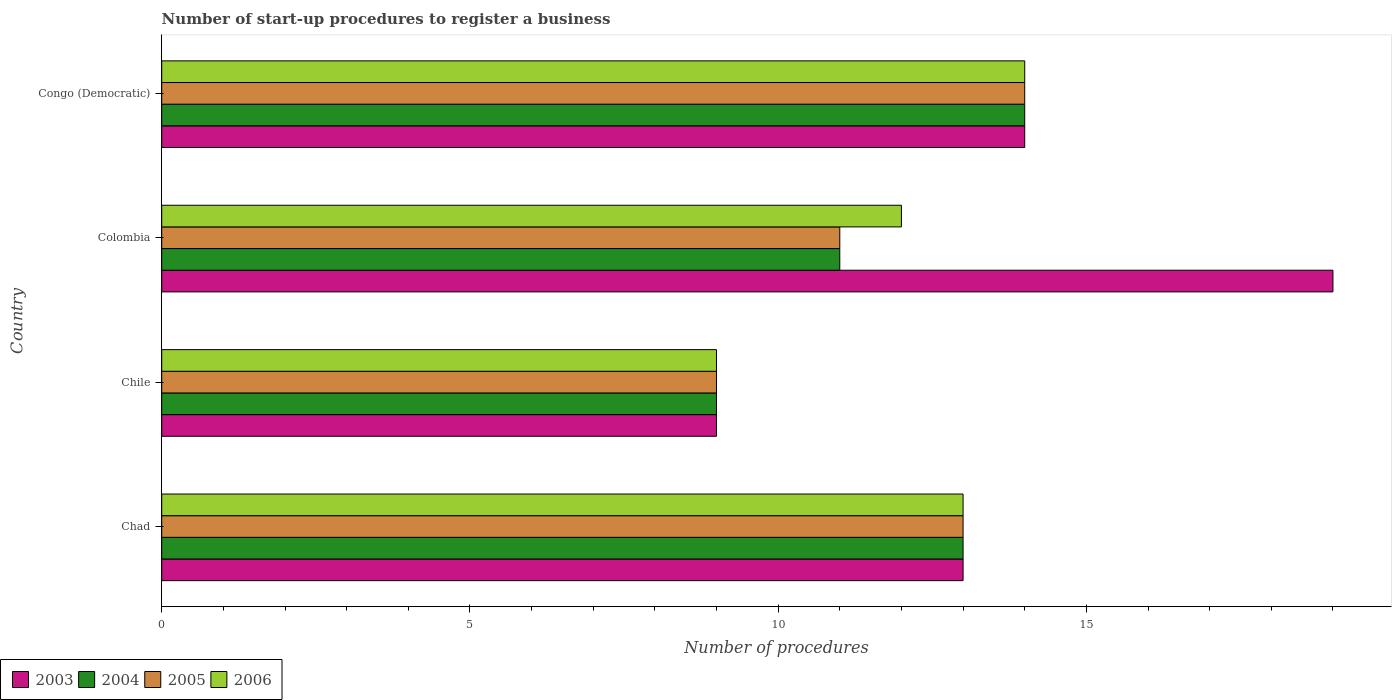How many different coloured bars are there?
Your answer should be very brief. 4. How many groups of bars are there?
Offer a very short reply. 4. Are the number of bars per tick equal to the number of legend labels?
Your response must be concise. Yes. Are the number of bars on each tick of the Y-axis equal?
Your response must be concise. Yes. How many bars are there on the 2nd tick from the top?
Keep it short and to the point. 4. How many bars are there on the 4th tick from the bottom?
Ensure brevity in your answer.  4. What is the label of the 3rd group of bars from the top?
Your answer should be very brief. Chile. What is the number of procedures required to register a business in 2005 in Congo (Democratic)?
Your answer should be very brief. 14. Across all countries, what is the maximum number of procedures required to register a business in 2005?
Ensure brevity in your answer.  14. Across all countries, what is the minimum number of procedures required to register a business in 2004?
Your answer should be very brief. 9. What is the total number of procedures required to register a business in 2005 in the graph?
Give a very brief answer. 47. What is the difference between the number of procedures required to register a business in 2006 in Chile and that in Congo (Democratic)?
Offer a very short reply. -5. What is the difference between the number of procedures required to register a business in 2004 in Congo (Democratic) and the number of procedures required to register a business in 2006 in Colombia?
Your answer should be compact. 2. What is the average number of procedures required to register a business in 2003 per country?
Make the answer very short. 13.75. In how many countries, is the number of procedures required to register a business in 2006 greater than 13 ?
Provide a short and direct response. 1. What is the ratio of the number of procedures required to register a business in 2003 in Colombia to that in Congo (Democratic)?
Provide a short and direct response. 1.36. Is the number of procedures required to register a business in 2005 in Colombia less than that in Congo (Democratic)?
Your answer should be very brief. Yes. In how many countries, is the number of procedures required to register a business in 2004 greater than the average number of procedures required to register a business in 2004 taken over all countries?
Give a very brief answer. 2. Is it the case that in every country, the sum of the number of procedures required to register a business in 2006 and number of procedures required to register a business in 2003 is greater than the sum of number of procedures required to register a business in 2005 and number of procedures required to register a business in 2004?
Provide a succinct answer. No. What does the 1st bar from the top in Congo (Democratic) represents?
Ensure brevity in your answer.  2006. Are all the bars in the graph horizontal?
Offer a very short reply. Yes. How many countries are there in the graph?
Provide a short and direct response. 4. What is the difference between two consecutive major ticks on the X-axis?
Your response must be concise. 5. Are the values on the major ticks of X-axis written in scientific E-notation?
Your answer should be very brief. No. Where does the legend appear in the graph?
Your answer should be compact. Bottom left. What is the title of the graph?
Keep it short and to the point. Number of start-up procedures to register a business. Does "1994" appear as one of the legend labels in the graph?
Your answer should be compact. No. What is the label or title of the X-axis?
Ensure brevity in your answer.  Number of procedures. What is the Number of procedures of 2004 in Chad?
Offer a terse response. 13. What is the Number of procedures in 2006 in Chad?
Offer a terse response. 13. What is the Number of procedures of 2005 in Chile?
Offer a terse response. 9. What is the Number of procedures in 2003 in Colombia?
Keep it short and to the point. 19. What is the Number of procedures in 2004 in Colombia?
Make the answer very short. 11. What is the Number of procedures in 2006 in Colombia?
Provide a succinct answer. 12. What is the Number of procedures of 2005 in Congo (Democratic)?
Keep it short and to the point. 14. What is the Number of procedures of 2006 in Congo (Democratic)?
Provide a short and direct response. 14. Across all countries, what is the maximum Number of procedures in 2003?
Provide a short and direct response. 19. Across all countries, what is the maximum Number of procedures of 2005?
Keep it short and to the point. 14. Across all countries, what is the minimum Number of procedures of 2005?
Your answer should be compact. 9. Across all countries, what is the minimum Number of procedures in 2006?
Keep it short and to the point. 9. What is the total Number of procedures in 2004 in the graph?
Your answer should be very brief. 47. What is the total Number of procedures of 2005 in the graph?
Keep it short and to the point. 47. What is the difference between the Number of procedures of 2005 in Chad and that in Chile?
Ensure brevity in your answer.  4. What is the difference between the Number of procedures in 2003 in Chad and that in Colombia?
Make the answer very short. -6. What is the difference between the Number of procedures of 2005 in Chad and that in Colombia?
Provide a succinct answer. 2. What is the difference between the Number of procedures of 2005 in Chad and that in Congo (Democratic)?
Your response must be concise. -1. What is the difference between the Number of procedures of 2006 in Chad and that in Congo (Democratic)?
Keep it short and to the point. -1. What is the difference between the Number of procedures in 2003 in Chile and that in Colombia?
Your answer should be compact. -10. What is the difference between the Number of procedures of 2005 in Chile and that in Colombia?
Offer a very short reply. -2. What is the difference between the Number of procedures in 2006 in Chile and that in Colombia?
Give a very brief answer. -3. What is the difference between the Number of procedures of 2003 in Chile and that in Congo (Democratic)?
Offer a very short reply. -5. What is the difference between the Number of procedures of 2005 in Chile and that in Congo (Democratic)?
Keep it short and to the point. -5. What is the difference between the Number of procedures of 2006 in Chile and that in Congo (Democratic)?
Give a very brief answer. -5. What is the difference between the Number of procedures in 2003 in Colombia and that in Congo (Democratic)?
Provide a succinct answer. 5. What is the difference between the Number of procedures in 2006 in Colombia and that in Congo (Democratic)?
Your answer should be very brief. -2. What is the difference between the Number of procedures of 2003 in Chad and the Number of procedures of 2005 in Chile?
Provide a succinct answer. 4. What is the difference between the Number of procedures in 2003 in Chad and the Number of procedures in 2006 in Chile?
Offer a very short reply. 4. What is the difference between the Number of procedures of 2004 in Chad and the Number of procedures of 2005 in Chile?
Your answer should be very brief. 4. What is the difference between the Number of procedures in 2004 in Chad and the Number of procedures in 2005 in Colombia?
Your answer should be compact. 2. What is the difference between the Number of procedures of 2004 in Chad and the Number of procedures of 2006 in Colombia?
Provide a short and direct response. 1. What is the difference between the Number of procedures in 2003 in Chad and the Number of procedures in 2005 in Congo (Democratic)?
Give a very brief answer. -1. What is the difference between the Number of procedures in 2005 in Chad and the Number of procedures in 2006 in Congo (Democratic)?
Make the answer very short. -1. What is the difference between the Number of procedures in 2003 in Colombia and the Number of procedures in 2004 in Congo (Democratic)?
Provide a succinct answer. 5. What is the difference between the Number of procedures in 2003 in Colombia and the Number of procedures in 2006 in Congo (Democratic)?
Your answer should be very brief. 5. What is the difference between the Number of procedures of 2004 in Colombia and the Number of procedures of 2006 in Congo (Democratic)?
Your answer should be very brief. -3. What is the average Number of procedures in 2003 per country?
Your answer should be very brief. 13.75. What is the average Number of procedures in 2004 per country?
Keep it short and to the point. 11.75. What is the average Number of procedures in 2005 per country?
Your answer should be very brief. 11.75. What is the difference between the Number of procedures in 2003 and Number of procedures in 2004 in Chad?
Offer a very short reply. 0. What is the difference between the Number of procedures of 2003 and Number of procedures of 2006 in Chad?
Offer a terse response. 0. What is the difference between the Number of procedures in 2004 and Number of procedures in 2005 in Chad?
Give a very brief answer. 0. What is the difference between the Number of procedures in 2005 and Number of procedures in 2006 in Chad?
Your answer should be very brief. 0. What is the difference between the Number of procedures of 2003 and Number of procedures of 2005 in Chile?
Offer a very short reply. 0. What is the difference between the Number of procedures of 2003 and Number of procedures of 2006 in Chile?
Give a very brief answer. 0. What is the difference between the Number of procedures of 2004 and Number of procedures of 2005 in Chile?
Keep it short and to the point. 0. What is the difference between the Number of procedures of 2003 and Number of procedures of 2004 in Colombia?
Ensure brevity in your answer.  8. What is the difference between the Number of procedures in 2003 and Number of procedures in 2005 in Colombia?
Provide a short and direct response. 8. What is the difference between the Number of procedures in 2003 and Number of procedures in 2006 in Colombia?
Make the answer very short. 7. What is the difference between the Number of procedures of 2003 and Number of procedures of 2004 in Congo (Democratic)?
Give a very brief answer. 0. What is the ratio of the Number of procedures in 2003 in Chad to that in Chile?
Offer a very short reply. 1.44. What is the ratio of the Number of procedures of 2004 in Chad to that in Chile?
Keep it short and to the point. 1.44. What is the ratio of the Number of procedures in 2005 in Chad to that in Chile?
Your answer should be compact. 1.44. What is the ratio of the Number of procedures of 2006 in Chad to that in Chile?
Your response must be concise. 1.44. What is the ratio of the Number of procedures of 2003 in Chad to that in Colombia?
Your response must be concise. 0.68. What is the ratio of the Number of procedures in 2004 in Chad to that in Colombia?
Keep it short and to the point. 1.18. What is the ratio of the Number of procedures of 2005 in Chad to that in Colombia?
Give a very brief answer. 1.18. What is the ratio of the Number of procedures of 2006 in Chad to that in Colombia?
Give a very brief answer. 1.08. What is the ratio of the Number of procedures of 2005 in Chad to that in Congo (Democratic)?
Keep it short and to the point. 0.93. What is the ratio of the Number of procedures in 2003 in Chile to that in Colombia?
Give a very brief answer. 0.47. What is the ratio of the Number of procedures of 2004 in Chile to that in Colombia?
Provide a short and direct response. 0.82. What is the ratio of the Number of procedures of 2005 in Chile to that in Colombia?
Offer a terse response. 0.82. What is the ratio of the Number of procedures of 2003 in Chile to that in Congo (Democratic)?
Your answer should be compact. 0.64. What is the ratio of the Number of procedures in 2004 in Chile to that in Congo (Democratic)?
Keep it short and to the point. 0.64. What is the ratio of the Number of procedures in 2005 in Chile to that in Congo (Democratic)?
Ensure brevity in your answer.  0.64. What is the ratio of the Number of procedures in 2006 in Chile to that in Congo (Democratic)?
Provide a short and direct response. 0.64. What is the ratio of the Number of procedures of 2003 in Colombia to that in Congo (Democratic)?
Offer a terse response. 1.36. What is the ratio of the Number of procedures in 2004 in Colombia to that in Congo (Democratic)?
Your response must be concise. 0.79. What is the ratio of the Number of procedures in 2005 in Colombia to that in Congo (Democratic)?
Keep it short and to the point. 0.79. What is the ratio of the Number of procedures in 2006 in Colombia to that in Congo (Democratic)?
Make the answer very short. 0.86. What is the difference between the highest and the second highest Number of procedures of 2004?
Give a very brief answer. 1. What is the difference between the highest and the second highest Number of procedures of 2005?
Offer a very short reply. 1. What is the difference between the highest and the lowest Number of procedures in 2004?
Offer a terse response. 5. 